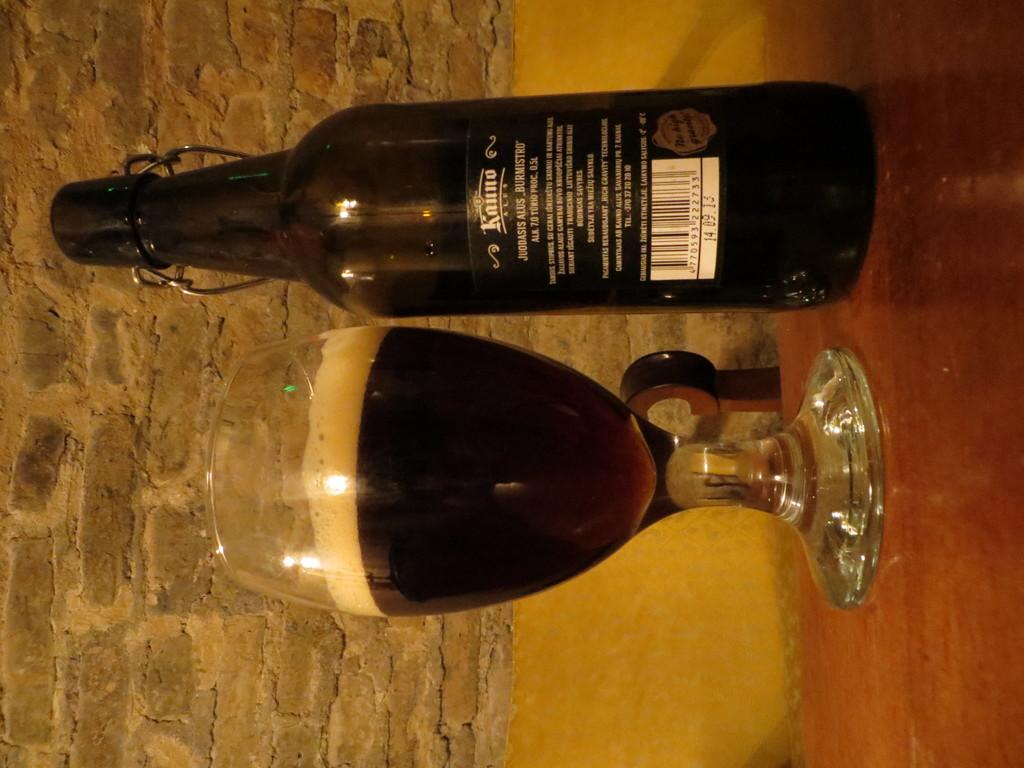Provide a one-sentence caption for the provided image. A bottle is marked 14.09.13 below the bar code. 